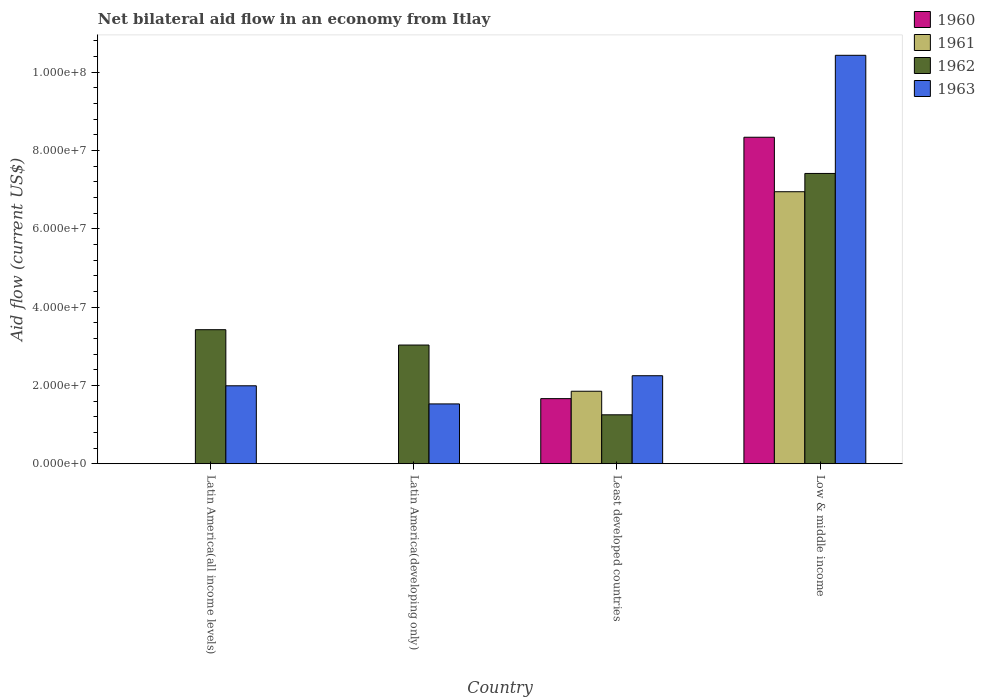How many different coloured bars are there?
Make the answer very short. 4. Are the number of bars per tick equal to the number of legend labels?
Keep it short and to the point. No. In how many cases, is the number of bars for a given country not equal to the number of legend labels?
Make the answer very short. 2. What is the net bilateral aid flow in 1963 in Latin America(developing only)?
Ensure brevity in your answer.  1.53e+07. Across all countries, what is the maximum net bilateral aid flow in 1963?
Offer a terse response. 1.04e+08. Across all countries, what is the minimum net bilateral aid flow in 1963?
Your answer should be compact. 1.53e+07. In which country was the net bilateral aid flow in 1962 maximum?
Your response must be concise. Low & middle income. What is the total net bilateral aid flow in 1960 in the graph?
Give a very brief answer. 1.00e+08. What is the difference between the net bilateral aid flow in 1962 in Latin America(all income levels) and that in Least developed countries?
Your answer should be very brief. 2.17e+07. What is the difference between the net bilateral aid flow in 1960 in Latin America(all income levels) and the net bilateral aid flow in 1962 in Latin America(developing only)?
Ensure brevity in your answer.  -3.03e+07. What is the average net bilateral aid flow in 1963 per country?
Keep it short and to the point. 4.05e+07. What is the difference between the net bilateral aid flow of/in 1963 and net bilateral aid flow of/in 1962 in Least developed countries?
Keep it short and to the point. 9.98e+06. What is the ratio of the net bilateral aid flow in 1962 in Least developed countries to that in Low & middle income?
Offer a very short reply. 0.17. Is the net bilateral aid flow in 1962 in Least developed countries less than that in Low & middle income?
Keep it short and to the point. Yes. What is the difference between the highest and the second highest net bilateral aid flow in 1963?
Ensure brevity in your answer.  8.44e+07. What is the difference between the highest and the lowest net bilateral aid flow in 1961?
Your answer should be compact. 6.95e+07. In how many countries, is the net bilateral aid flow in 1961 greater than the average net bilateral aid flow in 1961 taken over all countries?
Give a very brief answer. 1. Is it the case that in every country, the sum of the net bilateral aid flow in 1962 and net bilateral aid flow in 1961 is greater than the sum of net bilateral aid flow in 1960 and net bilateral aid flow in 1963?
Make the answer very short. No. Are all the bars in the graph horizontal?
Your response must be concise. No. Does the graph contain grids?
Your answer should be very brief. No. Where does the legend appear in the graph?
Make the answer very short. Top right. What is the title of the graph?
Your answer should be very brief. Net bilateral aid flow in an economy from Itlay. What is the Aid flow (current US$) of 1961 in Latin America(all income levels)?
Offer a terse response. 0. What is the Aid flow (current US$) of 1962 in Latin America(all income levels)?
Give a very brief answer. 3.42e+07. What is the Aid flow (current US$) of 1963 in Latin America(all income levels)?
Your response must be concise. 1.99e+07. What is the Aid flow (current US$) in 1960 in Latin America(developing only)?
Your response must be concise. 0. What is the Aid flow (current US$) of 1962 in Latin America(developing only)?
Provide a short and direct response. 3.03e+07. What is the Aid flow (current US$) of 1963 in Latin America(developing only)?
Your answer should be very brief. 1.53e+07. What is the Aid flow (current US$) of 1960 in Least developed countries?
Provide a succinct answer. 1.66e+07. What is the Aid flow (current US$) in 1961 in Least developed countries?
Your response must be concise. 1.85e+07. What is the Aid flow (current US$) of 1962 in Least developed countries?
Keep it short and to the point. 1.25e+07. What is the Aid flow (current US$) in 1963 in Least developed countries?
Your answer should be compact. 2.25e+07. What is the Aid flow (current US$) of 1960 in Low & middle income?
Offer a terse response. 8.34e+07. What is the Aid flow (current US$) of 1961 in Low & middle income?
Provide a short and direct response. 6.95e+07. What is the Aid flow (current US$) in 1962 in Low & middle income?
Your response must be concise. 7.42e+07. What is the Aid flow (current US$) in 1963 in Low & middle income?
Your answer should be compact. 1.04e+08. Across all countries, what is the maximum Aid flow (current US$) in 1960?
Give a very brief answer. 8.34e+07. Across all countries, what is the maximum Aid flow (current US$) of 1961?
Offer a terse response. 6.95e+07. Across all countries, what is the maximum Aid flow (current US$) of 1962?
Offer a very short reply. 7.42e+07. Across all countries, what is the maximum Aid flow (current US$) of 1963?
Provide a short and direct response. 1.04e+08. Across all countries, what is the minimum Aid flow (current US$) in 1961?
Ensure brevity in your answer.  0. Across all countries, what is the minimum Aid flow (current US$) of 1962?
Ensure brevity in your answer.  1.25e+07. Across all countries, what is the minimum Aid flow (current US$) in 1963?
Offer a very short reply. 1.53e+07. What is the total Aid flow (current US$) in 1960 in the graph?
Provide a succinct answer. 1.00e+08. What is the total Aid flow (current US$) of 1961 in the graph?
Your answer should be compact. 8.80e+07. What is the total Aid flow (current US$) in 1962 in the graph?
Keep it short and to the point. 1.51e+08. What is the total Aid flow (current US$) in 1963 in the graph?
Keep it short and to the point. 1.62e+08. What is the difference between the Aid flow (current US$) in 1962 in Latin America(all income levels) and that in Latin America(developing only)?
Provide a succinct answer. 3.92e+06. What is the difference between the Aid flow (current US$) of 1963 in Latin America(all income levels) and that in Latin America(developing only)?
Make the answer very short. 4.63e+06. What is the difference between the Aid flow (current US$) of 1962 in Latin America(all income levels) and that in Least developed countries?
Ensure brevity in your answer.  2.17e+07. What is the difference between the Aid flow (current US$) of 1963 in Latin America(all income levels) and that in Least developed countries?
Keep it short and to the point. -2.57e+06. What is the difference between the Aid flow (current US$) of 1962 in Latin America(all income levels) and that in Low & middle income?
Your answer should be compact. -3.99e+07. What is the difference between the Aid flow (current US$) of 1963 in Latin America(all income levels) and that in Low & middle income?
Make the answer very short. -8.44e+07. What is the difference between the Aid flow (current US$) in 1962 in Latin America(developing only) and that in Least developed countries?
Provide a short and direct response. 1.78e+07. What is the difference between the Aid flow (current US$) in 1963 in Latin America(developing only) and that in Least developed countries?
Provide a succinct answer. -7.20e+06. What is the difference between the Aid flow (current US$) of 1962 in Latin America(developing only) and that in Low & middle income?
Ensure brevity in your answer.  -4.38e+07. What is the difference between the Aid flow (current US$) in 1963 in Latin America(developing only) and that in Low & middle income?
Your answer should be compact. -8.90e+07. What is the difference between the Aid flow (current US$) in 1960 in Least developed countries and that in Low & middle income?
Your answer should be compact. -6.68e+07. What is the difference between the Aid flow (current US$) in 1961 in Least developed countries and that in Low & middle income?
Your response must be concise. -5.10e+07. What is the difference between the Aid flow (current US$) of 1962 in Least developed countries and that in Low & middle income?
Offer a terse response. -6.16e+07. What is the difference between the Aid flow (current US$) of 1963 in Least developed countries and that in Low & middle income?
Your answer should be compact. -8.18e+07. What is the difference between the Aid flow (current US$) in 1962 in Latin America(all income levels) and the Aid flow (current US$) in 1963 in Latin America(developing only)?
Provide a succinct answer. 1.90e+07. What is the difference between the Aid flow (current US$) in 1962 in Latin America(all income levels) and the Aid flow (current US$) in 1963 in Least developed countries?
Keep it short and to the point. 1.18e+07. What is the difference between the Aid flow (current US$) in 1962 in Latin America(all income levels) and the Aid flow (current US$) in 1963 in Low & middle income?
Keep it short and to the point. -7.01e+07. What is the difference between the Aid flow (current US$) in 1962 in Latin America(developing only) and the Aid flow (current US$) in 1963 in Least developed countries?
Keep it short and to the point. 7.84e+06. What is the difference between the Aid flow (current US$) of 1962 in Latin America(developing only) and the Aid flow (current US$) of 1963 in Low & middle income?
Your answer should be very brief. -7.40e+07. What is the difference between the Aid flow (current US$) in 1960 in Least developed countries and the Aid flow (current US$) in 1961 in Low & middle income?
Offer a very short reply. -5.28e+07. What is the difference between the Aid flow (current US$) in 1960 in Least developed countries and the Aid flow (current US$) in 1962 in Low & middle income?
Your answer should be very brief. -5.75e+07. What is the difference between the Aid flow (current US$) in 1960 in Least developed countries and the Aid flow (current US$) in 1963 in Low & middle income?
Give a very brief answer. -8.77e+07. What is the difference between the Aid flow (current US$) in 1961 in Least developed countries and the Aid flow (current US$) in 1962 in Low & middle income?
Offer a terse response. -5.56e+07. What is the difference between the Aid flow (current US$) in 1961 in Least developed countries and the Aid flow (current US$) in 1963 in Low & middle income?
Ensure brevity in your answer.  -8.58e+07. What is the difference between the Aid flow (current US$) in 1962 in Least developed countries and the Aid flow (current US$) in 1963 in Low & middle income?
Offer a very short reply. -9.18e+07. What is the average Aid flow (current US$) of 1960 per country?
Ensure brevity in your answer.  2.50e+07. What is the average Aid flow (current US$) of 1961 per country?
Offer a terse response. 2.20e+07. What is the average Aid flow (current US$) of 1962 per country?
Your answer should be very brief. 3.78e+07. What is the average Aid flow (current US$) of 1963 per country?
Give a very brief answer. 4.05e+07. What is the difference between the Aid flow (current US$) of 1962 and Aid flow (current US$) of 1963 in Latin America(all income levels)?
Give a very brief answer. 1.43e+07. What is the difference between the Aid flow (current US$) in 1962 and Aid flow (current US$) in 1963 in Latin America(developing only)?
Provide a short and direct response. 1.50e+07. What is the difference between the Aid flow (current US$) in 1960 and Aid flow (current US$) in 1961 in Least developed countries?
Provide a succinct answer. -1.89e+06. What is the difference between the Aid flow (current US$) of 1960 and Aid flow (current US$) of 1962 in Least developed countries?
Offer a terse response. 4.13e+06. What is the difference between the Aid flow (current US$) of 1960 and Aid flow (current US$) of 1963 in Least developed countries?
Offer a terse response. -5.85e+06. What is the difference between the Aid flow (current US$) of 1961 and Aid flow (current US$) of 1962 in Least developed countries?
Offer a very short reply. 6.02e+06. What is the difference between the Aid flow (current US$) of 1961 and Aid flow (current US$) of 1963 in Least developed countries?
Offer a very short reply. -3.96e+06. What is the difference between the Aid flow (current US$) of 1962 and Aid flow (current US$) of 1963 in Least developed countries?
Your response must be concise. -9.98e+06. What is the difference between the Aid flow (current US$) of 1960 and Aid flow (current US$) of 1961 in Low & middle income?
Your response must be concise. 1.39e+07. What is the difference between the Aid flow (current US$) in 1960 and Aid flow (current US$) in 1962 in Low & middle income?
Provide a succinct answer. 9.25e+06. What is the difference between the Aid flow (current US$) of 1960 and Aid flow (current US$) of 1963 in Low & middle income?
Keep it short and to the point. -2.09e+07. What is the difference between the Aid flow (current US$) of 1961 and Aid flow (current US$) of 1962 in Low & middle income?
Give a very brief answer. -4.67e+06. What is the difference between the Aid flow (current US$) of 1961 and Aid flow (current US$) of 1963 in Low & middle income?
Ensure brevity in your answer.  -3.48e+07. What is the difference between the Aid flow (current US$) in 1962 and Aid flow (current US$) in 1963 in Low & middle income?
Make the answer very short. -3.02e+07. What is the ratio of the Aid flow (current US$) of 1962 in Latin America(all income levels) to that in Latin America(developing only)?
Ensure brevity in your answer.  1.13. What is the ratio of the Aid flow (current US$) in 1963 in Latin America(all income levels) to that in Latin America(developing only)?
Your answer should be very brief. 1.3. What is the ratio of the Aid flow (current US$) in 1962 in Latin America(all income levels) to that in Least developed countries?
Keep it short and to the point. 2.74. What is the ratio of the Aid flow (current US$) in 1963 in Latin America(all income levels) to that in Least developed countries?
Provide a succinct answer. 0.89. What is the ratio of the Aid flow (current US$) of 1962 in Latin America(all income levels) to that in Low & middle income?
Your answer should be very brief. 0.46. What is the ratio of the Aid flow (current US$) of 1963 in Latin America(all income levels) to that in Low & middle income?
Offer a terse response. 0.19. What is the ratio of the Aid flow (current US$) of 1962 in Latin America(developing only) to that in Least developed countries?
Provide a short and direct response. 2.43. What is the ratio of the Aid flow (current US$) of 1963 in Latin America(developing only) to that in Least developed countries?
Your answer should be very brief. 0.68. What is the ratio of the Aid flow (current US$) in 1962 in Latin America(developing only) to that in Low & middle income?
Provide a short and direct response. 0.41. What is the ratio of the Aid flow (current US$) in 1963 in Latin America(developing only) to that in Low & middle income?
Your answer should be very brief. 0.15. What is the ratio of the Aid flow (current US$) in 1960 in Least developed countries to that in Low & middle income?
Provide a succinct answer. 0.2. What is the ratio of the Aid flow (current US$) in 1961 in Least developed countries to that in Low & middle income?
Provide a short and direct response. 0.27. What is the ratio of the Aid flow (current US$) in 1962 in Least developed countries to that in Low & middle income?
Your answer should be compact. 0.17. What is the ratio of the Aid flow (current US$) in 1963 in Least developed countries to that in Low & middle income?
Your answer should be very brief. 0.22. What is the difference between the highest and the second highest Aid flow (current US$) in 1962?
Provide a succinct answer. 3.99e+07. What is the difference between the highest and the second highest Aid flow (current US$) in 1963?
Offer a very short reply. 8.18e+07. What is the difference between the highest and the lowest Aid flow (current US$) in 1960?
Provide a succinct answer. 8.34e+07. What is the difference between the highest and the lowest Aid flow (current US$) of 1961?
Offer a terse response. 6.95e+07. What is the difference between the highest and the lowest Aid flow (current US$) of 1962?
Provide a succinct answer. 6.16e+07. What is the difference between the highest and the lowest Aid flow (current US$) in 1963?
Your answer should be compact. 8.90e+07. 